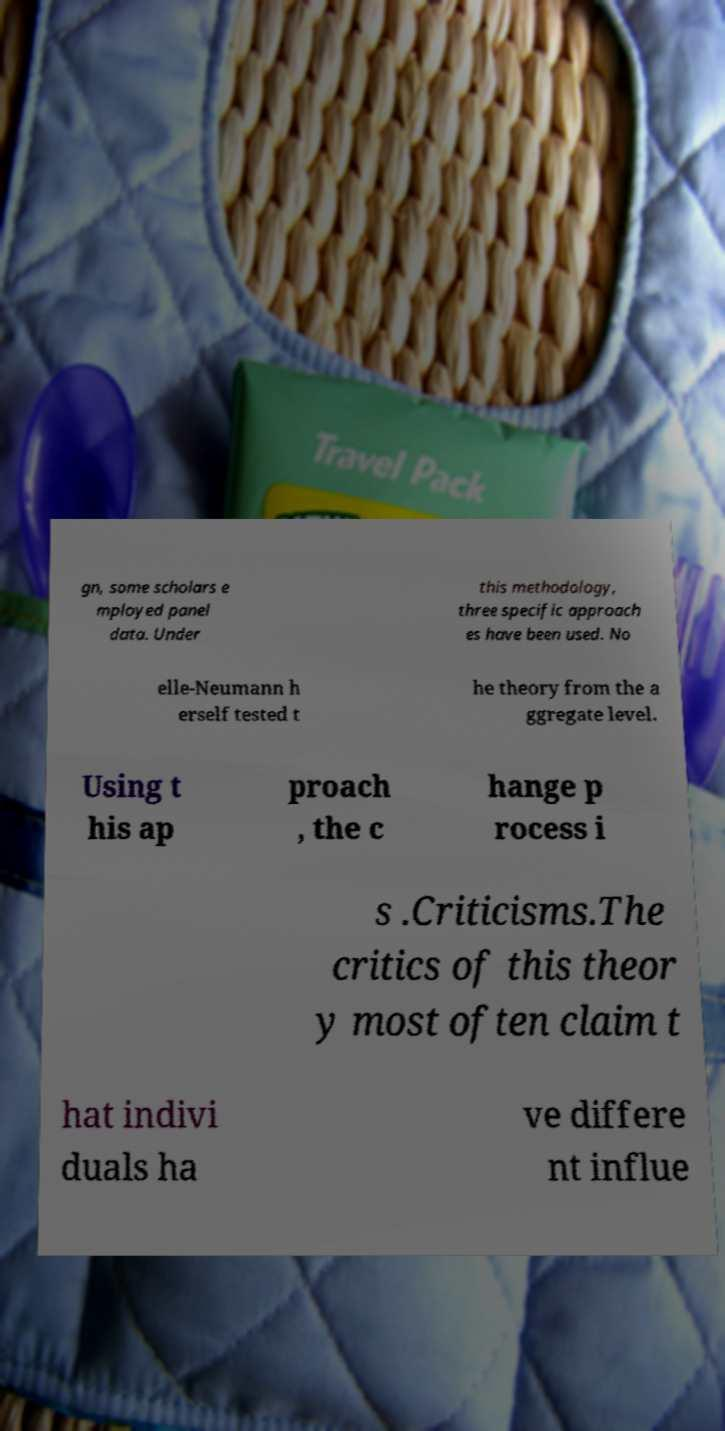Please identify and transcribe the text found in this image. gn, some scholars e mployed panel data. Under this methodology, three specific approach es have been used. No elle-Neumann h erself tested t he theory from the a ggregate level. Using t his ap proach , the c hange p rocess i s .Criticisms.The critics of this theor y most often claim t hat indivi duals ha ve differe nt influe 